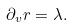Convert formula to latex. <formula><loc_0><loc_0><loc_500><loc_500>\partial _ { v } r = \lambda .</formula> 